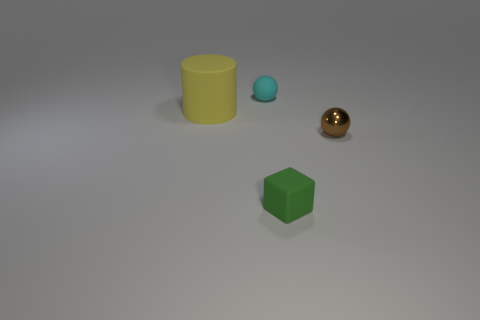Add 1 small matte objects. How many objects exist? 5 Subtract all blocks. How many objects are left? 3 Subtract 1 brown balls. How many objects are left? 3 Subtract all tiny matte cubes. Subtract all tiny yellow matte balls. How many objects are left? 3 Add 3 brown balls. How many brown balls are left? 4 Add 3 big cylinders. How many big cylinders exist? 4 